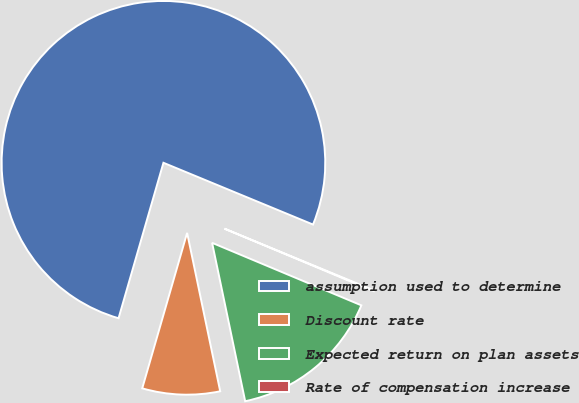<chart> <loc_0><loc_0><loc_500><loc_500><pie_chart><fcel>assumption used to determine<fcel>Discount rate<fcel>Expected return on plan assets<fcel>Rate of compensation increase<nl><fcel>76.76%<fcel>7.75%<fcel>15.41%<fcel>0.08%<nl></chart> 